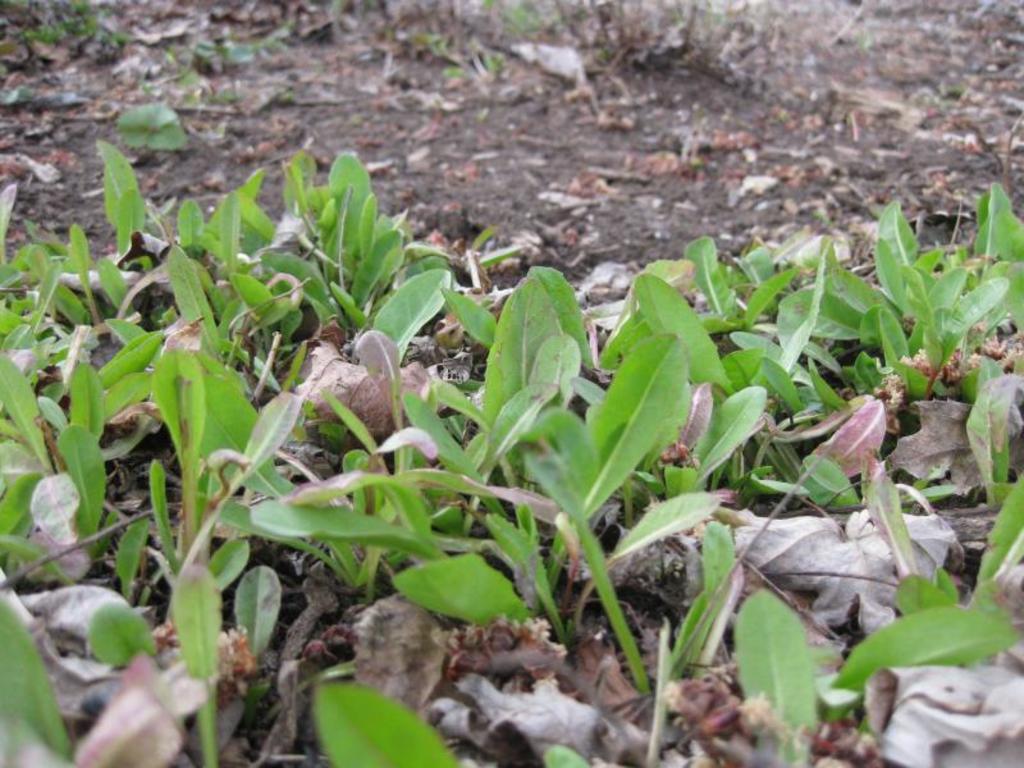Could you give a brief overview of what you see in this image? In this image on the ground there are plants and dried leaves. 